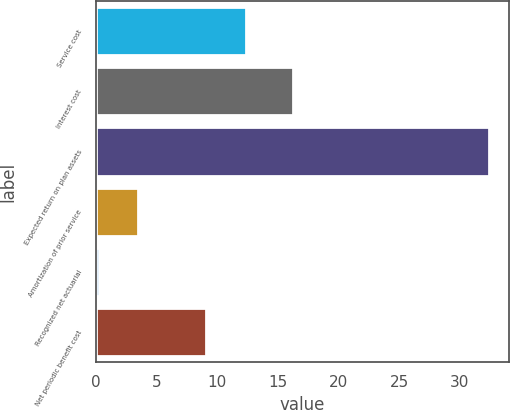<chart> <loc_0><loc_0><loc_500><loc_500><bar_chart><fcel>Service cost<fcel>Interest cost<fcel>Expected return on plan assets<fcel>Amortization of prior service<fcel>Recognized net actuarial<fcel>Net periodic benefit cost<nl><fcel>12.32<fcel>16.2<fcel>32.4<fcel>3.42<fcel>0.2<fcel>9.1<nl></chart> 